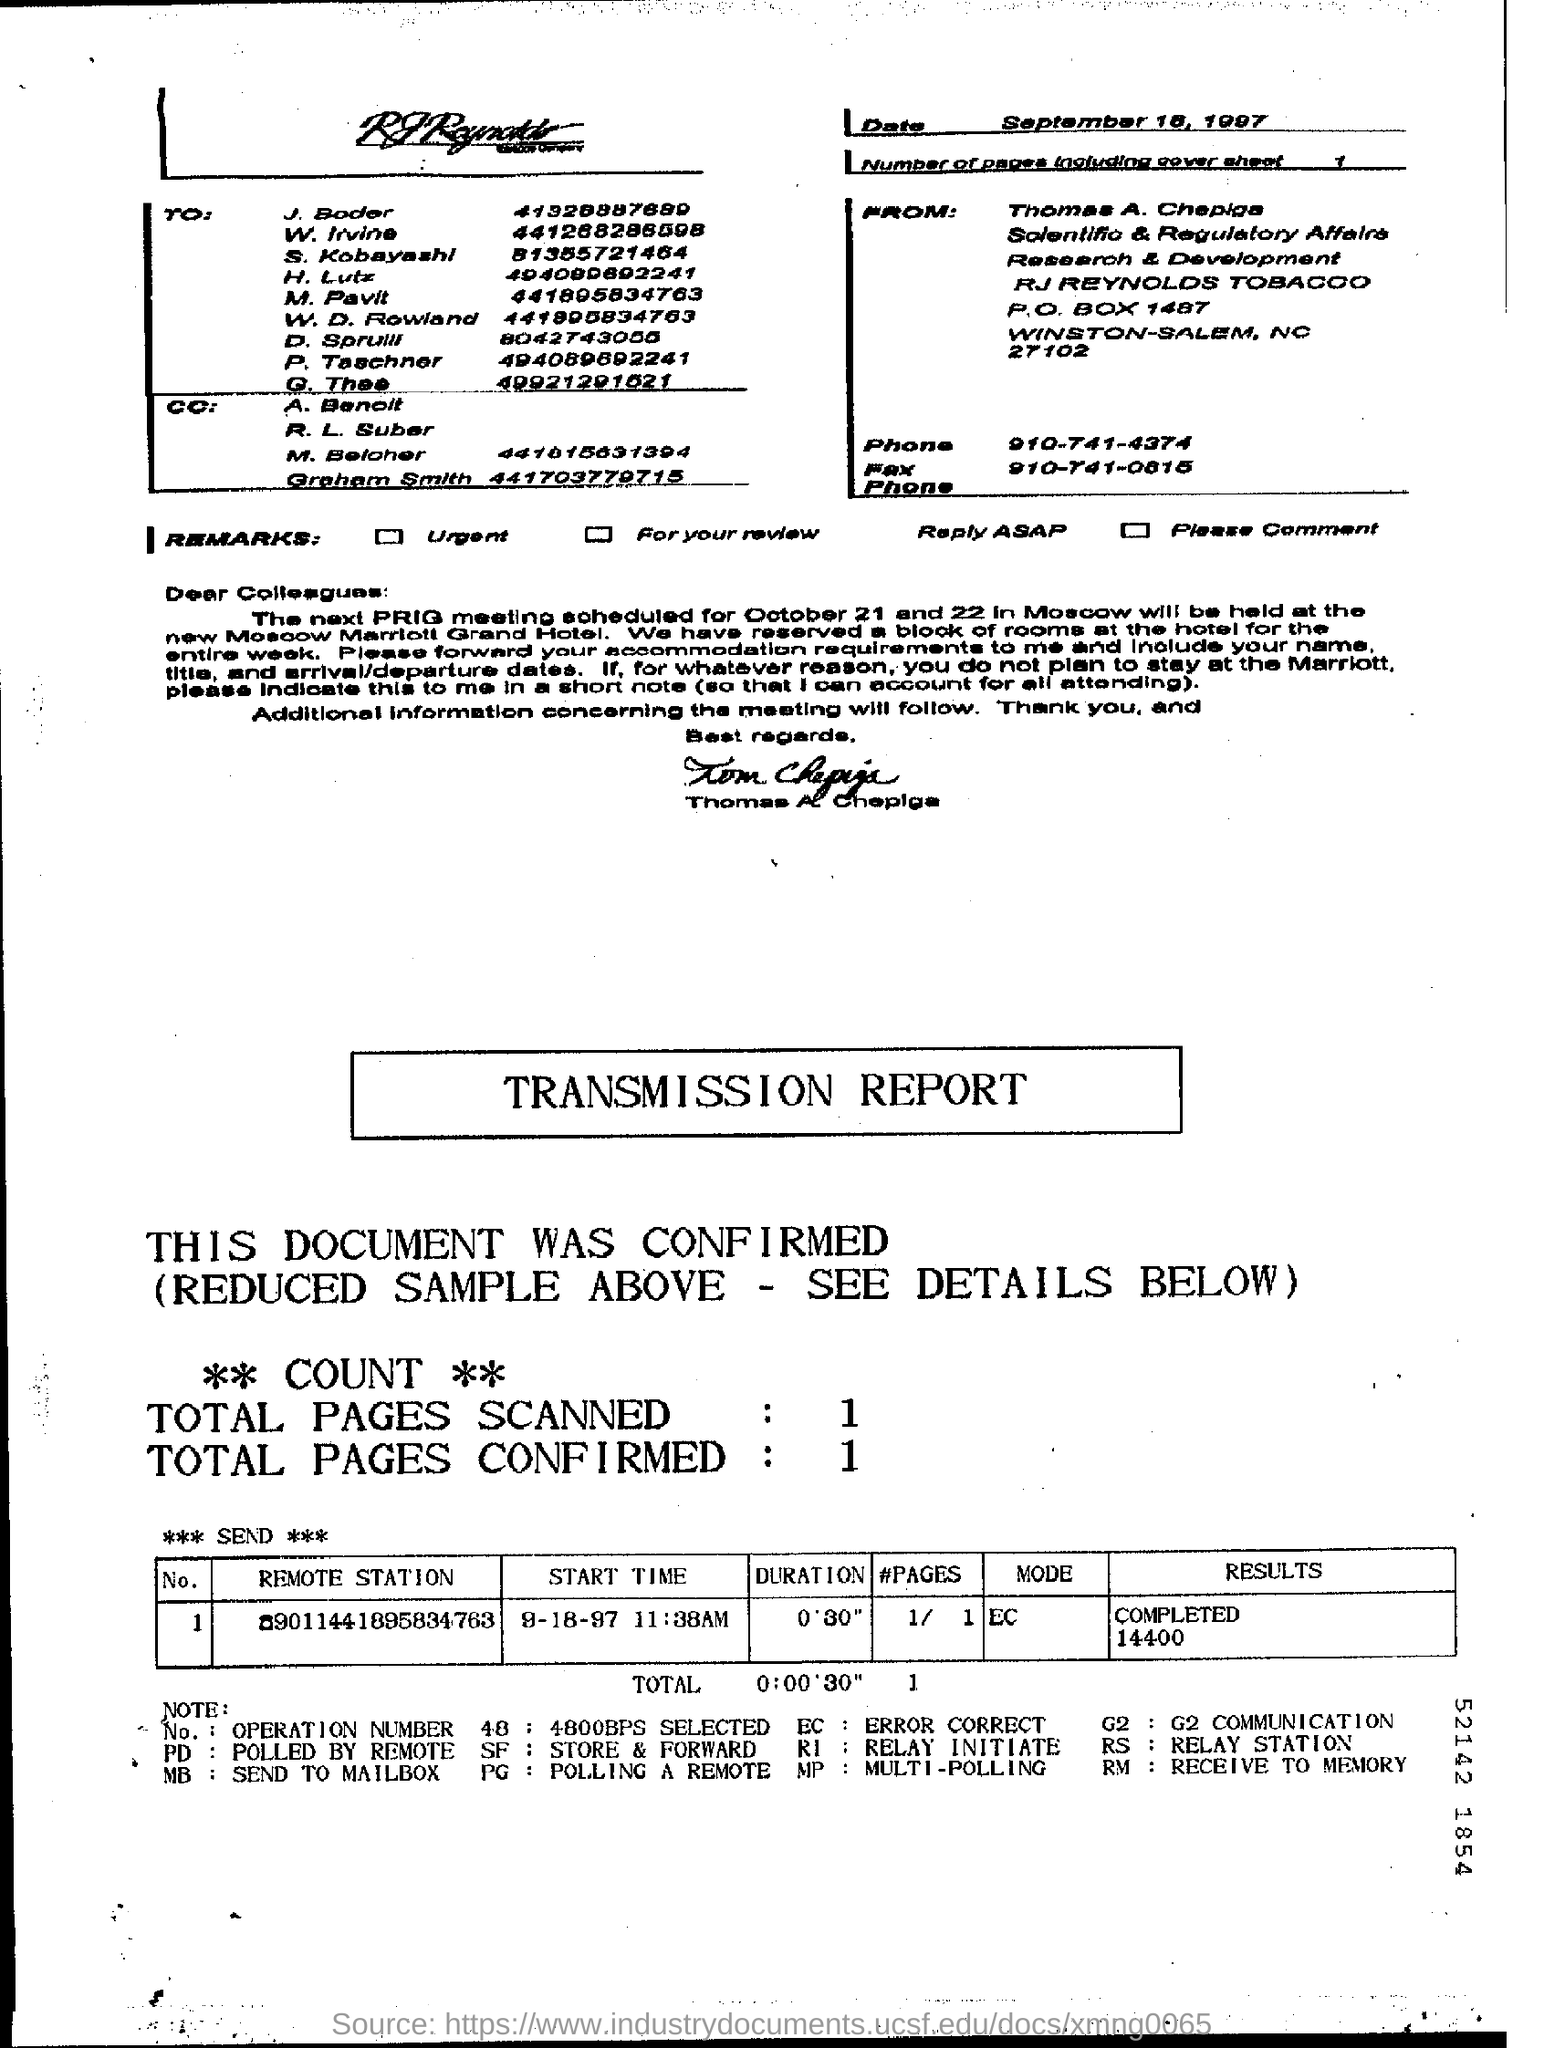Who is the sender of the fax?
Make the answer very short. Thomas A. Chepiga. What is the Fax phone no of Thomas A. Chepiga?
Provide a short and direct response. 910-741-0815. What is the number of pages in the fax including cover sheet?
Provide a short and direct response. 1. What is the mode given in the transmission report?
Make the answer very short. EC. What is the duration mentioned in the transmission report?
Your answer should be very brief. 0'30". What is the Phone No of Thomas A. Chepiga?
Your answer should be compact. 910-741-4374. What is the Start time mentioned in the transmission report?
Provide a succinct answer. 9-18-97 11:38AM. 